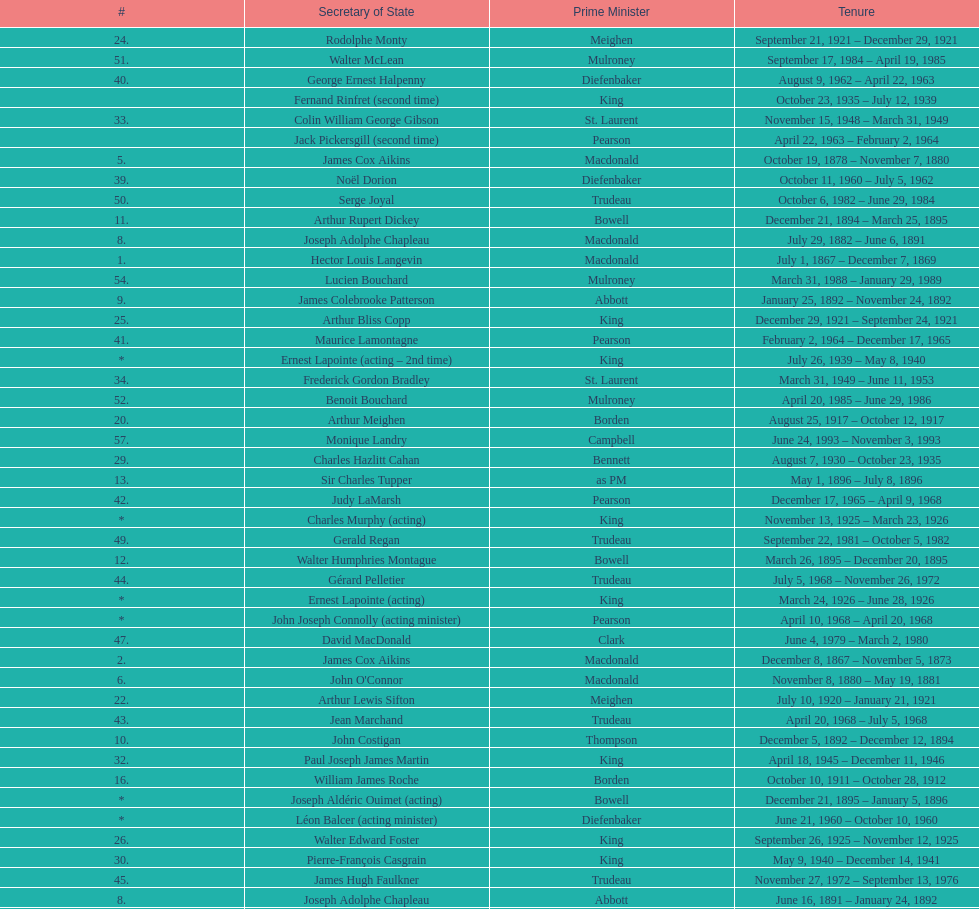What secretary of state served under both prime minister laurier and prime minister king? Charles Murphy. 